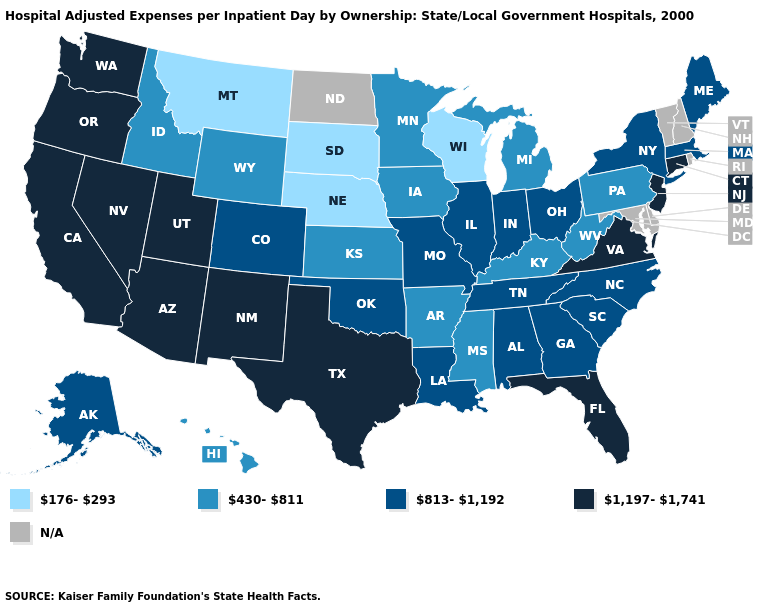What is the value of Colorado?
Short answer required. 813-1,192. Does the map have missing data?
Keep it brief. Yes. Name the states that have a value in the range 813-1,192?
Answer briefly. Alabama, Alaska, Colorado, Georgia, Illinois, Indiana, Louisiana, Maine, Massachusetts, Missouri, New York, North Carolina, Ohio, Oklahoma, South Carolina, Tennessee. What is the value of New Jersey?
Answer briefly. 1,197-1,741. Does Massachusetts have the lowest value in the Northeast?
Quick response, please. No. Does the map have missing data?
Be succinct. Yes. Which states have the highest value in the USA?
Give a very brief answer. Arizona, California, Connecticut, Florida, Nevada, New Jersey, New Mexico, Oregon, Texas, Utah, Virginia, Washington. Is the legend a continuous bar?
Give a very brief answer. No. Name the states that have a value in the range 813-1,192?
Answer briefly. Alabama, Alaska, Colorado, Georgia, Illinois, Indiana, Louisiana, Maine, Massachusetts, Missouri, New York, North Carolina, Ohio, Oklahoma, South Carolina, Tennessee. Does Texas have the highest value in the USA?
Quick response, please. Yes. Among the states that border Oklahoma , which have the lowest value?
Concise answer only. Arkansas, Kansas. Which states hav the highest value in the Northeast?
Concise answer only. Connecticut, New Jersey. Among the states that border Georgia , which have the highest value?
Keep it brief. Florida. What is the lowest value in the USA?
Keep it brief. 176-293. 